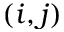Convert formula to latex. <formula><loc_0><loc_0><loc_500><loc_500>( i , j )</formula> 